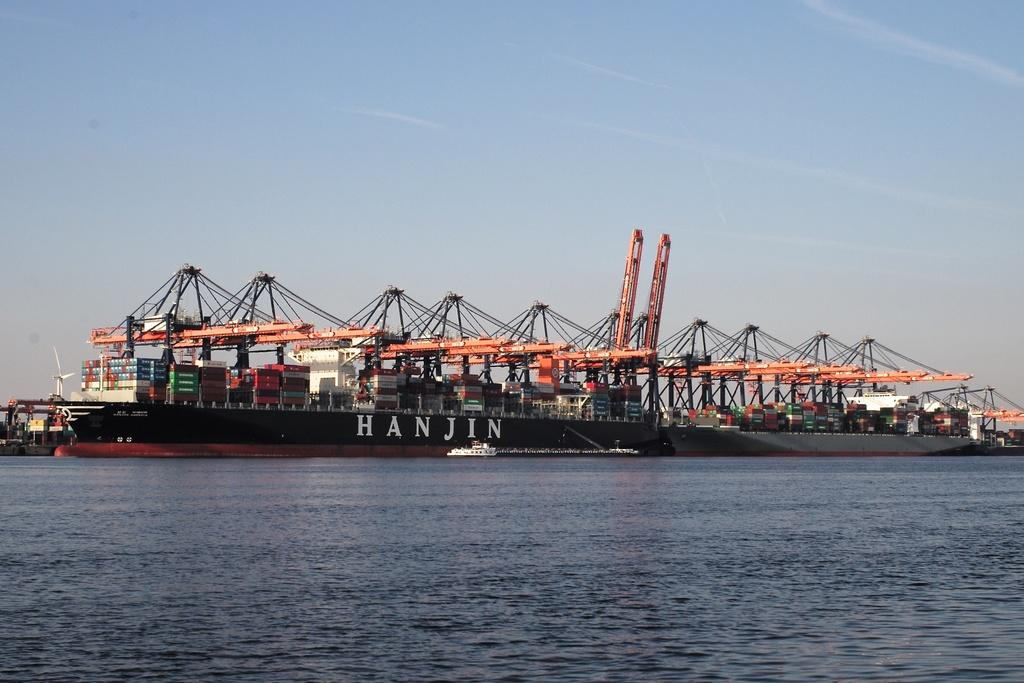<image>
Summarize the visual content of the image. A shipping boat called Hajin is floating in the water. 